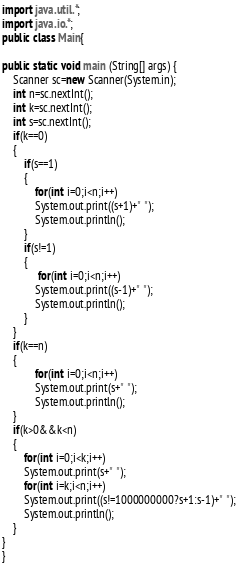Convert code to text. <code><loc_0><loc_0><loc_500><loc_500><_Java_>import java.util.*;
import java.io.*;
public class Main{
   
public static void main (String[] args) {
    Scanner sc=new Scanner(System.in);
    int n=sc.nextInt();
    int k=sc.nextInt();
    int s=sc.nextInt();
    if(k==0)
    {
        if(s==1)
        {
            for(int i=0;i<n;i++)
            System.out.print((s+1)+" ");
            System.out.println();
        }
        if(s!=1)
        {
             for(int i=0;i<n;i++)
            System.out.print((s-1)+" ");
            System.out.println();
        }
    }
    if(k==n)
    {
            for(int i=0;i<n;i++)
            System.out.print(s+" ");
            System.out.println();
    }
    if(k>0&&k<n)
    {
        for(int i=0;i<k;i++)
        System.out.print(s+" ");
        for(int i=k;i<n;i++)
        System.out.print((s!=1000000000?s+1:s-1)+" ");
        System.out.println();
    }
}
}</code> 